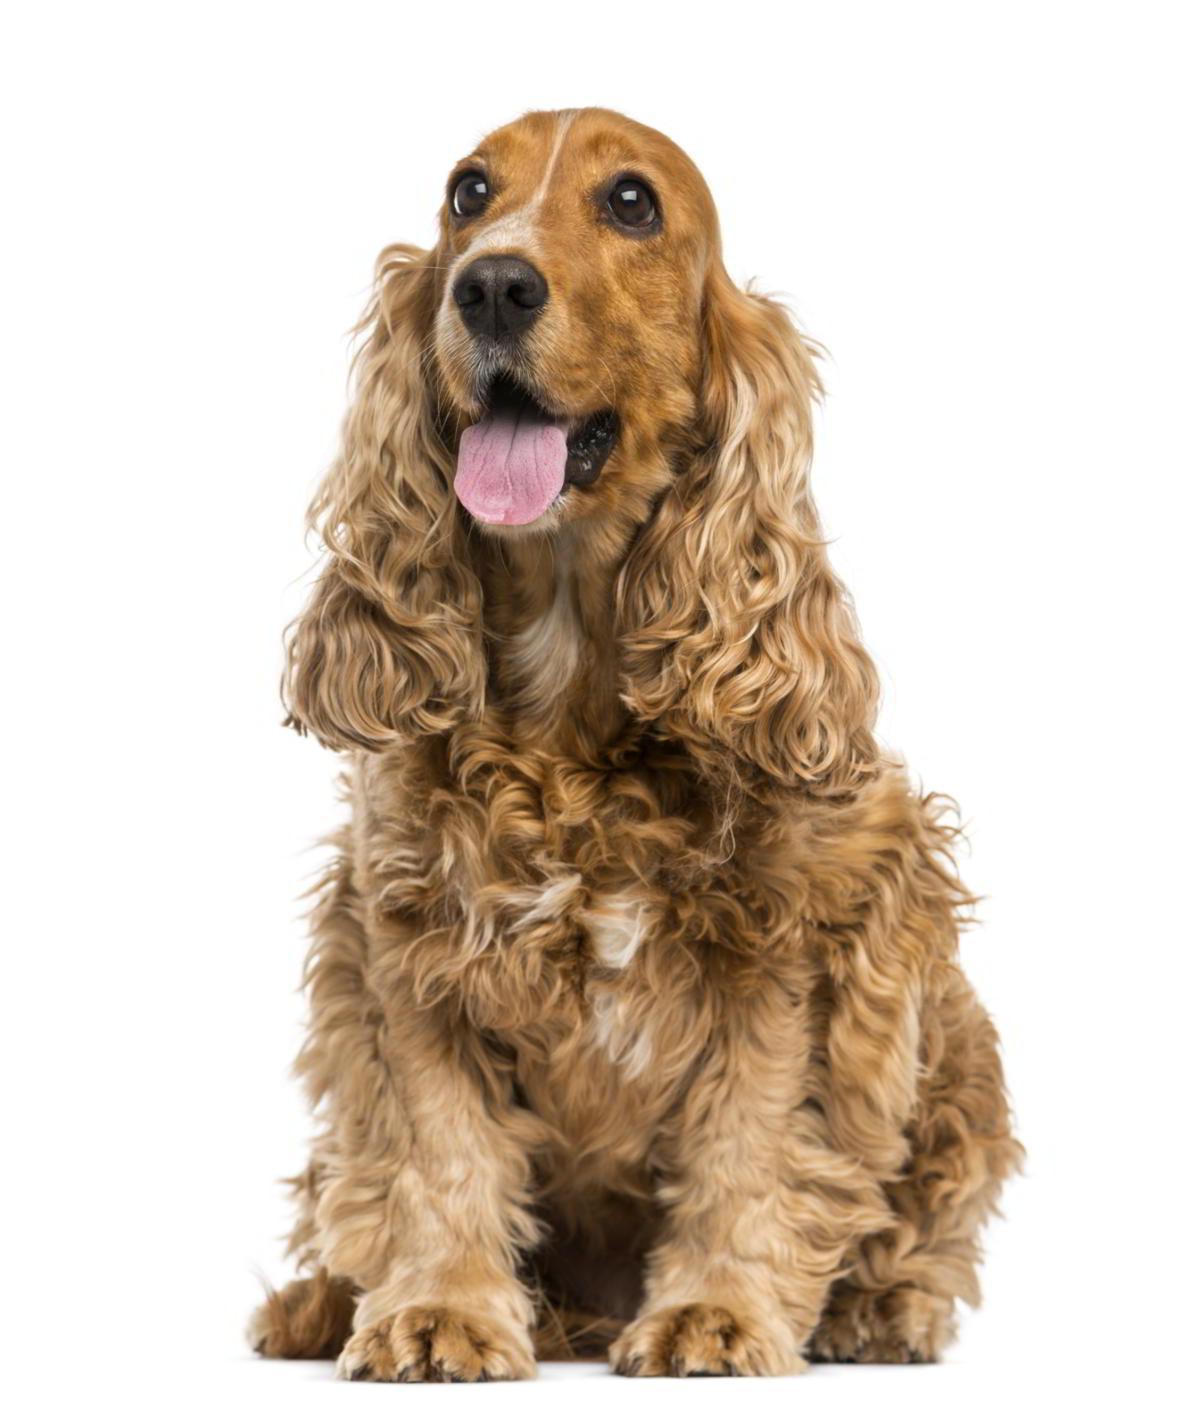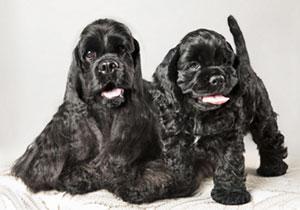The first image is the image on the left, the second image is the image on the right. For the images shown, is this caption "There are two dogs facing forward with their tongues out in the image on the right." true? Answer yes or no. Yes. The first image is the image on the left, the second image is the image on the right. Examine the images to the left and right. Is the description "There is at least one dog with some black fur." accurate? Answer yes or no. Yes. 